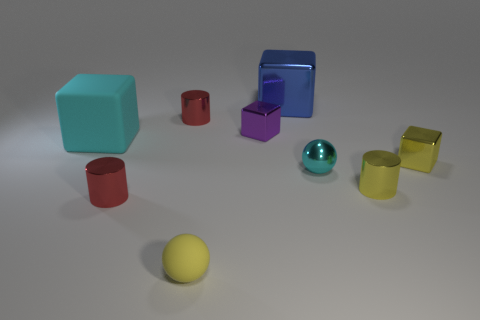There is a large blue shiny object; does it have the same shape as the matte thing that is behind the tiny yellow metallic cylinder?
Ensure brevity in your answer.  Yes. What is the material of the blue block?
Your answer should be compact. Metal. The cyan thing that is the same shape as the blue metallic thing is what size?
Your answer should be very brief. Large. What number of other objects are there of the same material as the large cyan object?
Provide a short and direct response. 1. Do the blue object and the red thing in front of the yellow block have the same material?
Your answer should be very brief. Yes. Are there fewer small blocks that are to the left of the small yellow metal block than tiny yellow things that are in front of the big blue thing?
Ensure brevity in your answer.  Yes. There is a cube on the right side of the big blue cube; what color is it?
Offer a very short reply. Yellow. What number of other objects are there of the same color as the matte cube?
Ensure brevity in your answer.  1. Is the size of the red metallic cylinder that is in front of the yellow cube the same as the blue thing?
Offer a very short reply. No. There is a purple shiny cube; what number of blocks are behind it?
Provide a succinct answer. 1. 